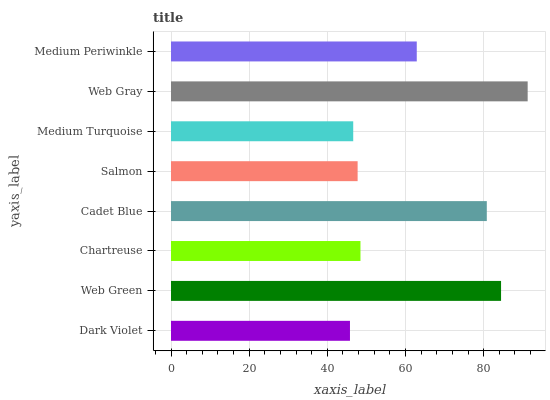Is Dark Violet the minimum?
Answer yes or no. Yes. Is Web Gray the maximum?
Answer yes or no. Yes. Is Web Green the minimum?
Answer yes or no. No. Is Web Green the maximum?
Answer yes or no. No. Is Web Green greater than Dark Violet?
Answer yes or no. Yes. Is Dark Violet less than Web Green?
Answer yes or no. Yes. Is Dark Violet greater than Web Green?
Answer yes or no. No. Is Web Green less than Dark Violet?
Answer yes or no. No. Is Medium Periwinkle the high median?
Answer yes or no. Yes. Is Chartreuse the low median?
Answer yes or no. Yes. Is Dark Violet the high median?
Answer yes or no. No. Is Web Green the low median?
Answer yes or no. No. 